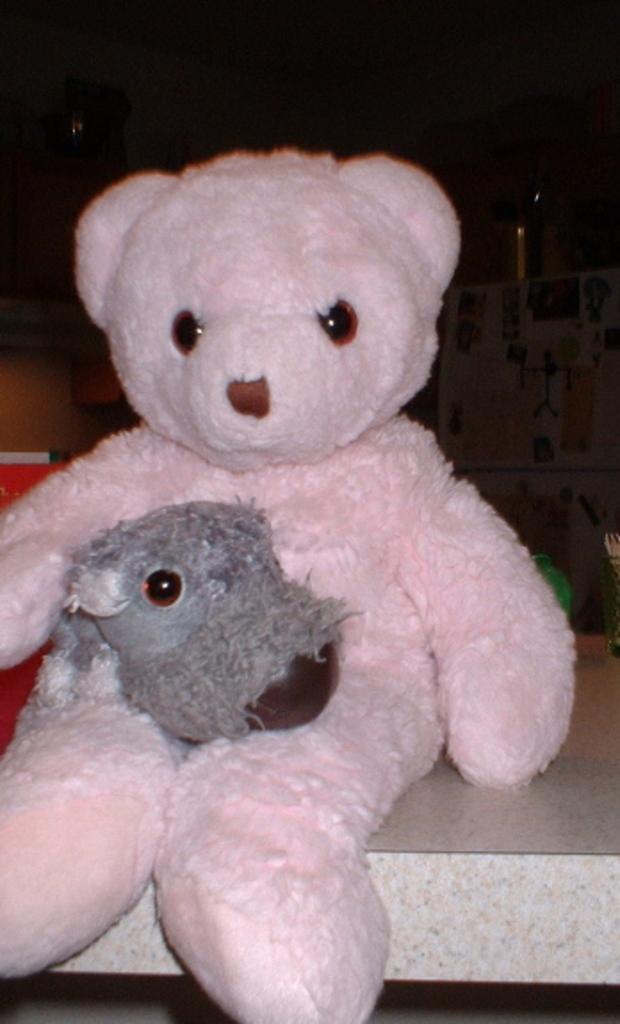What is the color of the doll in the image? The doll is white in color. Where is the doll located in the image? The doll is in the middle of the image. What is the doll placed on in the image? The doll is kept on a white colored object. What type of territory does the doll claim in the image? There is no indication of the doll claiming any territory in the image. 